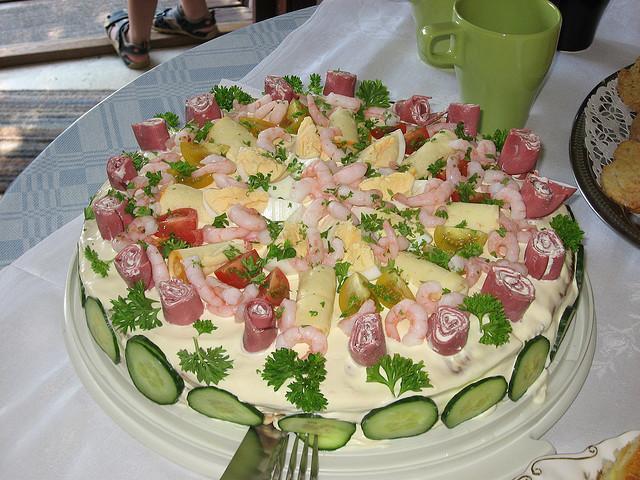How many cups are in the picture?
Give a very brief answer. 2. 